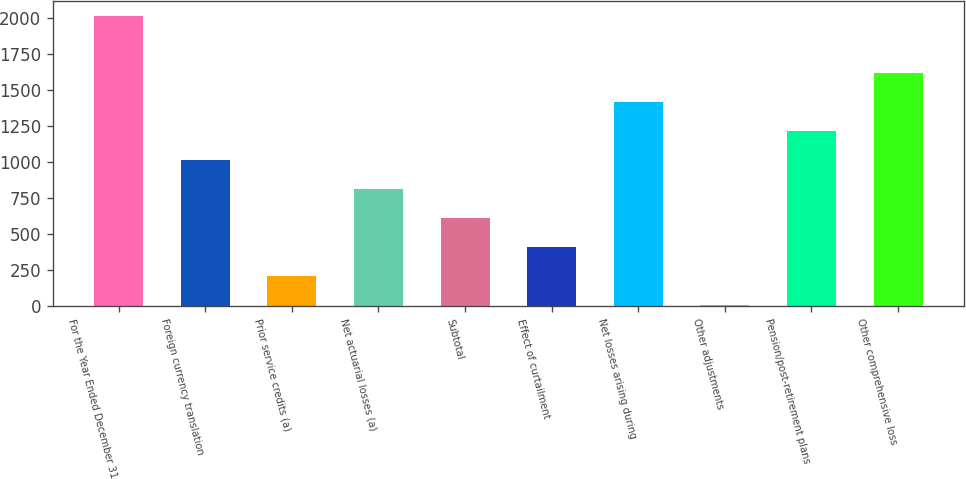<chart> <loc_0><loc_0><loc_500><loc_500><bar_chart><fcel>For the Year Ended December 31<fcel>Foreign currency translation<fcel>Prior service credits (a)<fcel>Net actuarial losses (a)<fcel>Subtotal<fcel>Effect of curtailment<fcel>Net losses arising during<fcel>Other adjustments<fcel>Pension/post-retirement plans<fcel>Other comprehensive loss<nl><fcel>2014<fcel>1011<fcel>208.6<fcel>810.4<fcel>609.8<fcel>409.2<fcel>1418<fcel>8<fcel>1211.6<fcel>1618.6<nl></chart> 